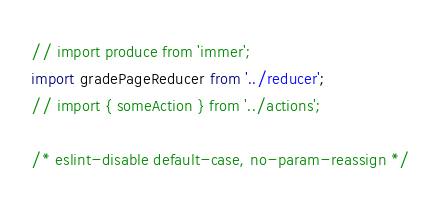Convert code to text. <code><loc_0><loc_0><loc_500><loc_500><_JavaScript_>// import produce from 'immer';
import gradePageReducer from '../reducer';
// import { someAction } from '../actions';

/* eslint-disable default-case, no-param-reassign */</code> 